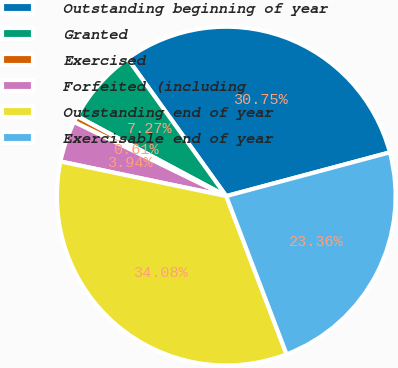Convert chart to OTSL. <chart><loc_0><loc_0><loc_500><loc_500><pie_chart><fcel>Outstanding beginning of year<fcel>Granted<fcel>Exercised<fcel>Forfeited (including<fcel>Outstanding end of year<fcel>Exercisable end of year<nl><fcel>30.75%<fcel>7.27%<fcel>0.61%<fcel>3.94%<fcel>34.08%<fcel>23.36%<nl></chart> 